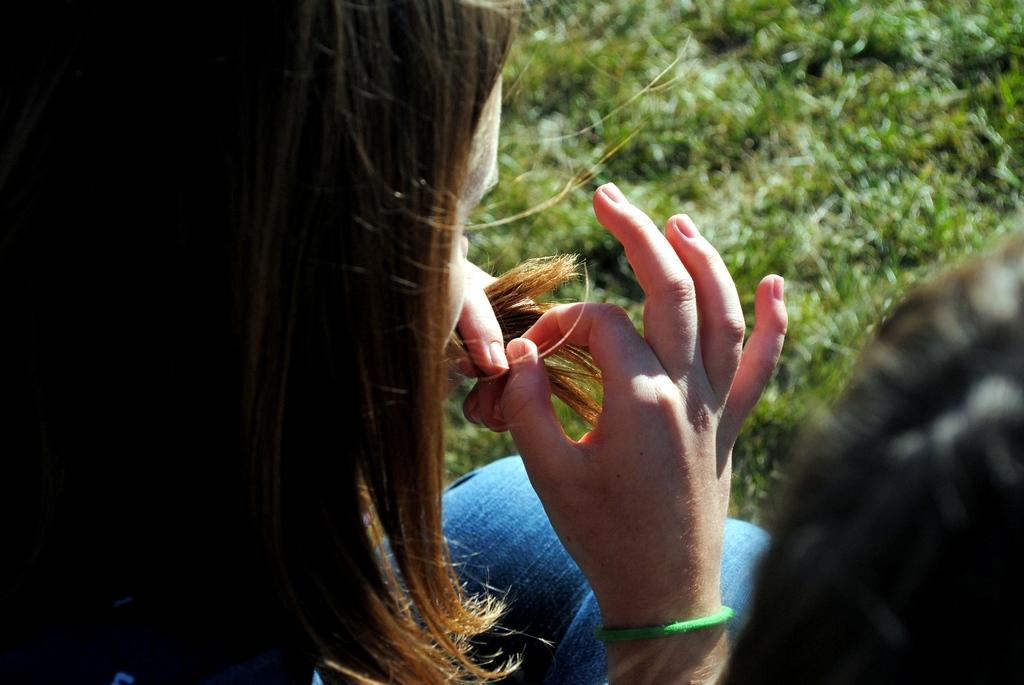Who is the main subject of the subject in the image? There is a woman in the image. What is the woman doing with her hair? The woman is holding her hair with her hands. What type of surface is in front of the woman? There is grass in front of the woman. Can you describe the other person in the image? There is another person on the right side bottom of the image. What type of friction can be seen between the woman's hair and her hands in the image? There is no specific friction visible between the woman's hair and her hands in the image. Can you tell me how many pins are holding the woman's hair in the image? There are no pins visible in the image; the woman is holding her hair with her hands. 